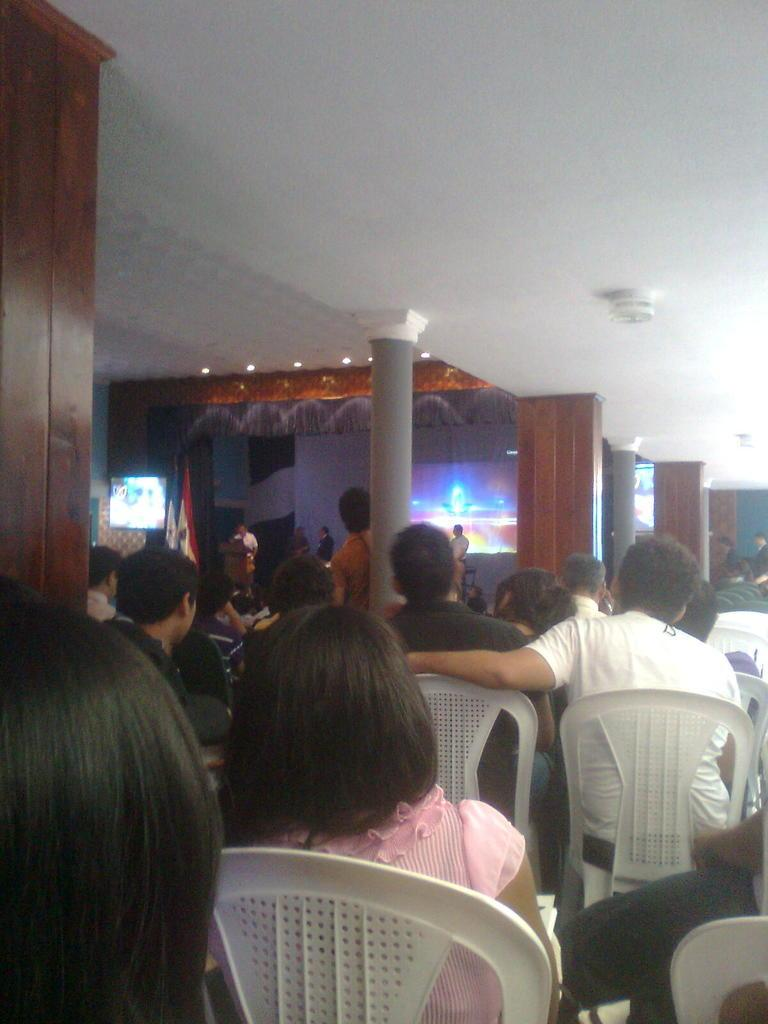How many people are sitting in the chairs in the image? There are many people sitting in the chairs in the image. Can you describe the gender distribution of the people in the hall? There are both men and women in the hall. What can be seen on the wall in the background? There is a projector display display screen in the background. What architectural features are present in the background? There are pillars in the background. What type of covering is present in the background? There is a curtain in the background. Where is the cactus located in the image? There is no cactus present in the image. How many pigs are visible in the image? There are no pigs visible in the image. 